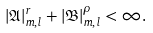<formula> <loc_0><loc_0><loc_500><loc_500>| \mathfrak { A } | _ { m , l } ^ { r } + | \mathfrak { B } | _ { m , l } ^ { \rho } < \infty .</formula> 